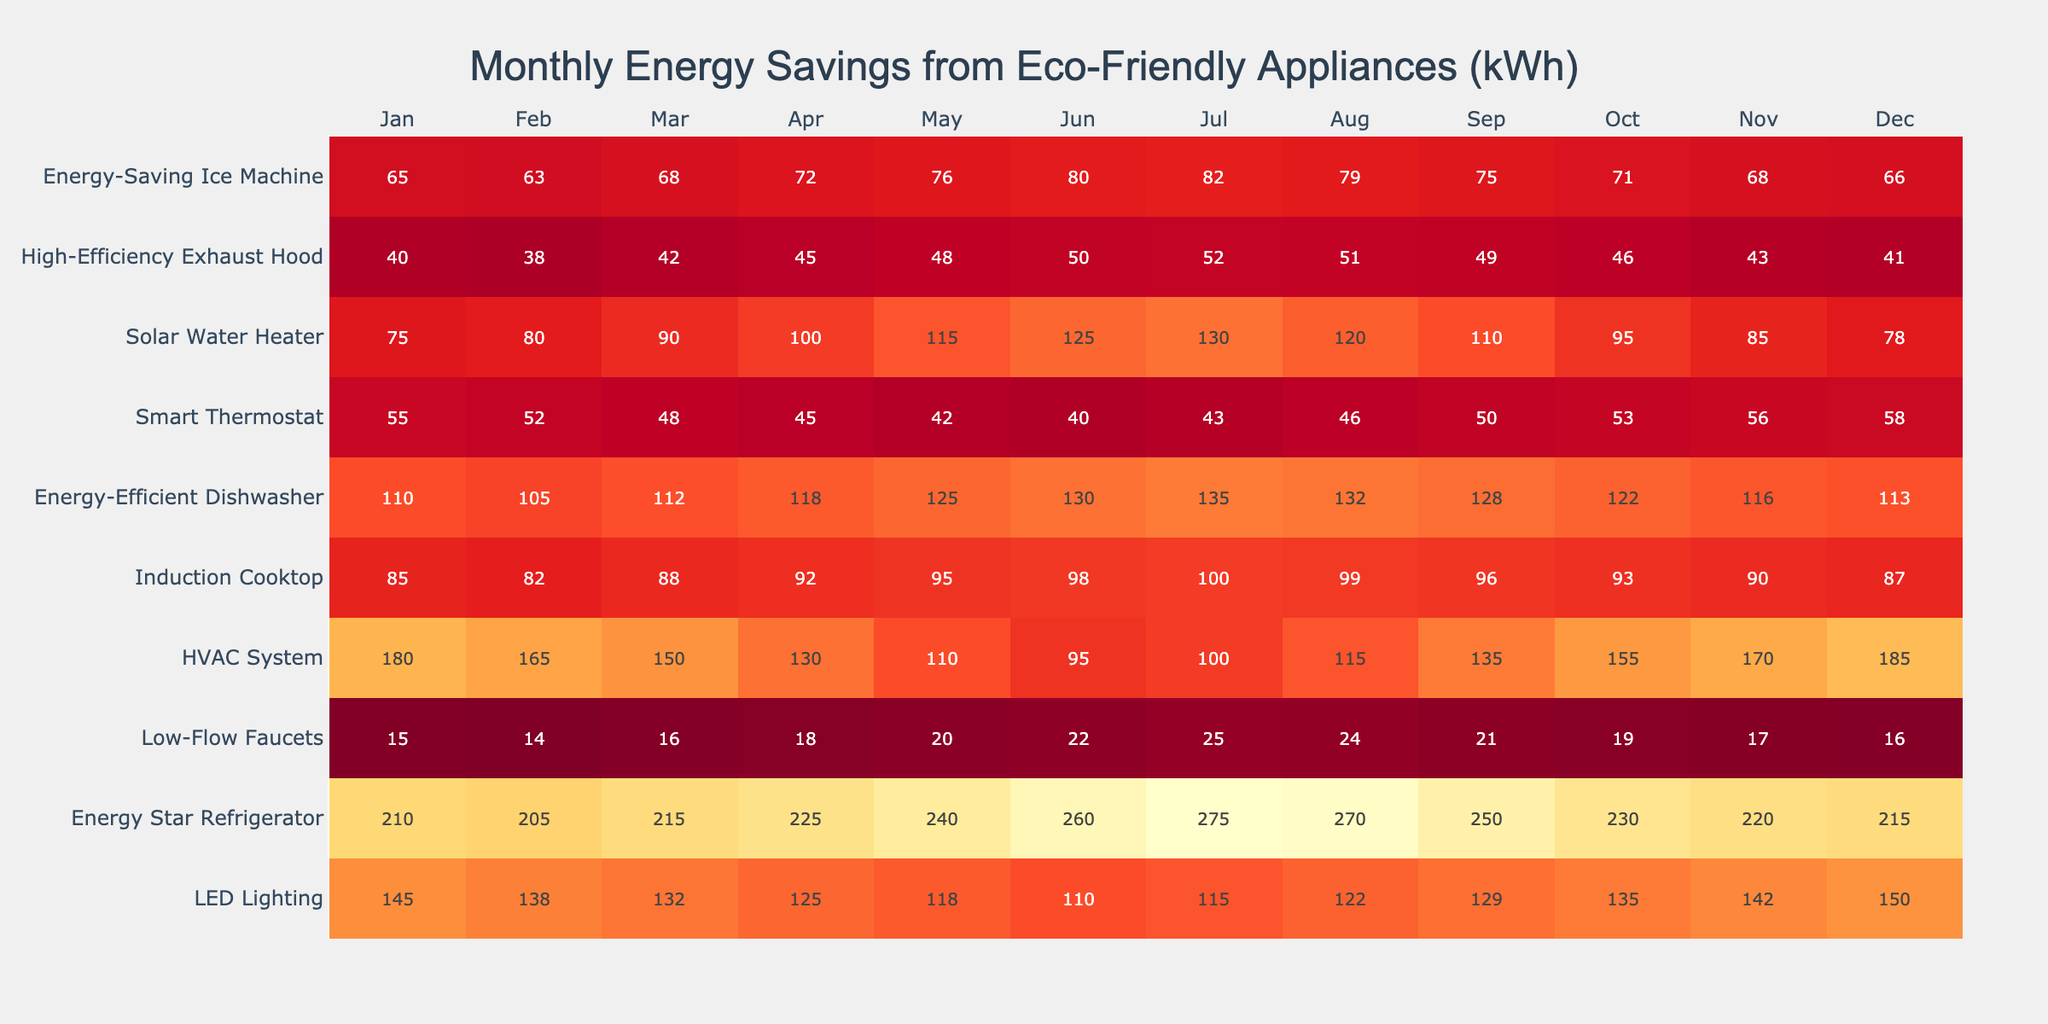What is the energy savings for the Energy Star Refrigerator in June? The table shows the monthly energy savings for the Energy Star Refrigerator as 260 kWh in June.
Answer: 260 kWh Which appliance has the highest energy savings in January? In January, the Energy Star Refrigerator has the highest energy savings listed, with 210 kWh.
Answer: Energy Star Refrigerator What are the energy savings from Low-Flow Faucets in April compared to November? The energy savings for Low-Flow Faucets in April is 18 kWh and in November is 17 kWh. The difference is 18 - 17 = 1 kWh.
Answer: 1 kWh What is the average monthly energy savings for the Induction Cooktop throughout the year? The total energy savings for the Induction Cooktop is (85 + 82 + 88 + 92 + 95 + 98 + 100 + 99 + 96 + 93 + 90 + 87) = 1116 kWh, and there are 12 months, so the average is 1116/12 = 93.
Answer: 93 kWh Is the energy savings for the Smart Thermostat in December greater than the energy savings for the HVAC System in January? The Smart Thermostat energy savings in December is 58 kWh and the HVAC System in January is 180 kWh. Since 58 is not greater than 180, the answer is no.
Answer: No What was the maximum energy savings for the Solar Water Heater, and in which month did it occur? The maximum energy savings for the Solar Water Heater is 130 kWh, which occurred in July.
Answer: 130 kWh in July Calculate the total energy savings for all appliances in March. The total energy savings for March is calculated by summing the values: 132 (LED) + 215 (Refrigerator) + 16 (Faucets) + 150 (HVAC) + 88 (Cooktop) + 112 (Dishwasher) + 48 (Thermostat) + 90 (Water Heater) + 42 (Hood) + 68 (Ice Machine) = 1,117 kWh.
Answer: 1,117 kWh Which month had the lowest total energy savings across all appliances? By comparing the totals, the month with the lowest total energy savings is June, which sums to 1,018 kWh.
Answer: June At what percentage did energy savings increase for the Energy-Efficient Dishwasher from October to November? The energy savings for the Dishwasher in October is 122 kWh and in November is 116 kWh. The percentage change is ((116 - 122) / 122) * 100 = -4.92%, indicating a decrease.
Answer: -4.92% Determine whether the sum of energy savings for the High-Efficiency Exhaust Hood exceeds 500 kWh for the year? The total for the High-Efficiency Exhaust Hood is (40 + 38 + 42 + 45 + 48 + 50 + 52 + 51 + 49 + 46 + 43 + 41) =  499 kWh, which does not exceed 500 kWh.
Answer: No 